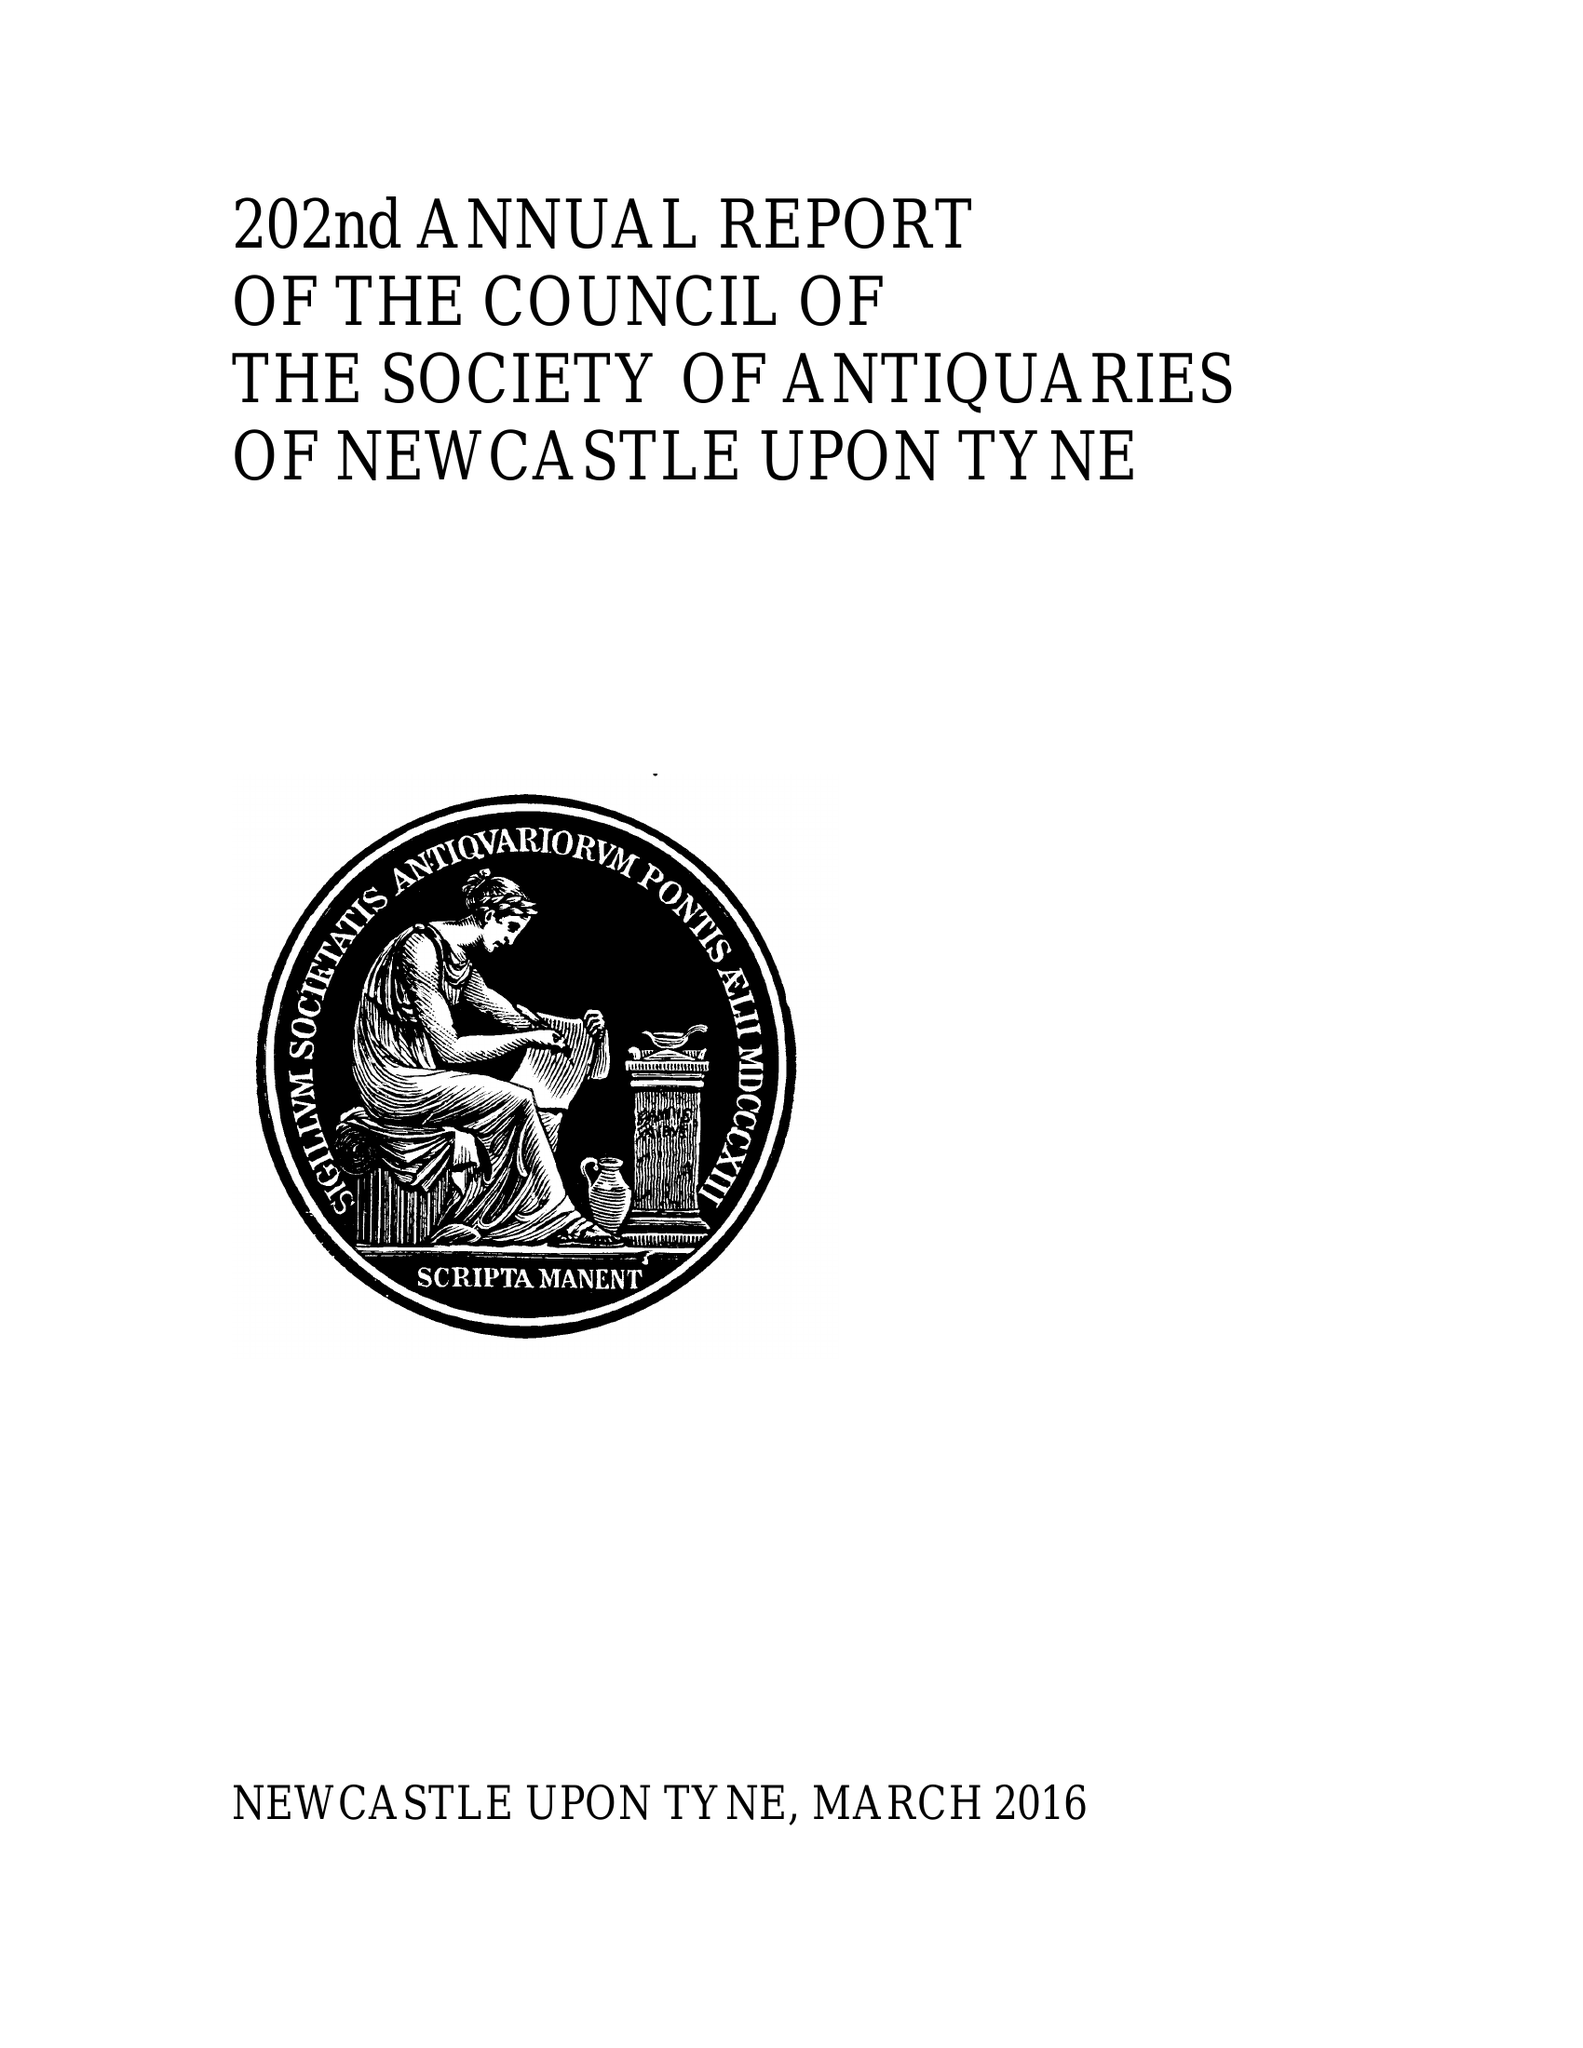What is the value for the address__post_town?
Answer the question using a single word or phrase. NEWCASTLE UPON TYNE 